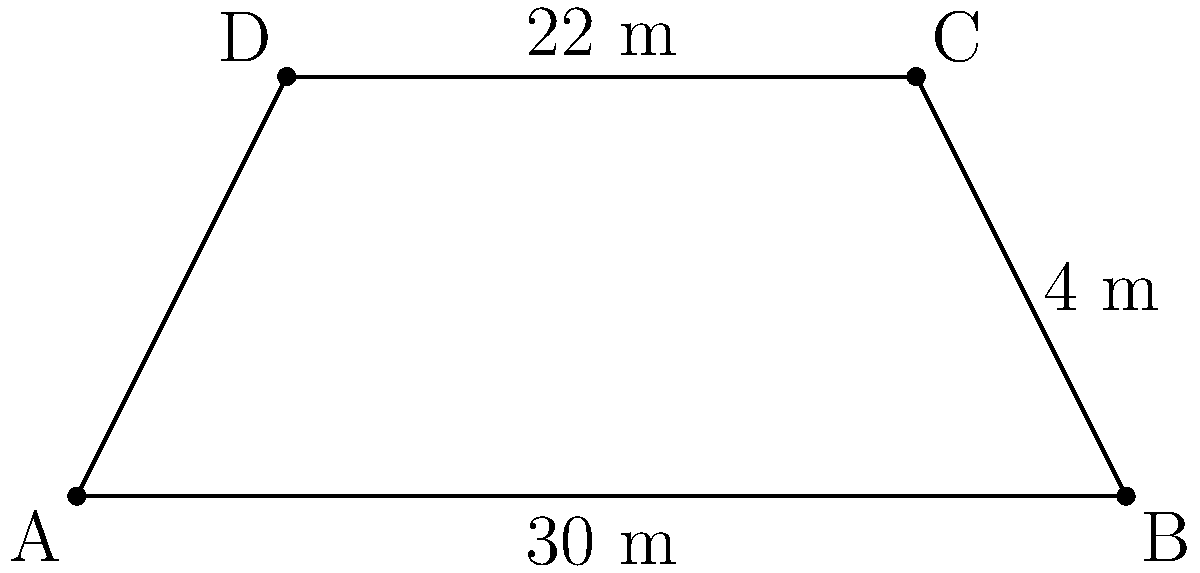As part of your duty to maintain order while respecting artistic expression, you've been tasked with calculating the area of a trapezoidal "free expression zone" for legal street art. The zone has parallel sides measuring 30 m and 22 m, with a height of 4 m between them. What is the area of this designated art space in square meters? To calculate the area of a trapezoid, we can use the formula:

$$A = \frac{1}{2}(b_1 + b_2)h$$

Where:
$A$ = Area of the trapezoid
$b_1$ = Length of one parallel side
$b_2$ = Length of the other parallel side
$h$ = Height (perpendicular distance between the parallel sides)

Given:
$b_1 = 30$ m
$b_2 = 22$ m
$h = 4$ m

Let's substitute these values into the formula:

$$A = \frac{1}{2}(30 \text{ m} + 22 \text{ m}) \times 4 \text{ m}$$

$$A = \frac{1}{2}(52 \text{ m}) \times 4 \text{ m}$$

$$A = 26 \text{ m} \times 4 \text{ m}$$

$$A = 104 \text{ m}^2$$

Therefore, the area of the "free expression zone" is 104 square meters.
Answer: 104 m² 